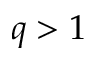<formula> <loc_0><loc_0><loc_500><loc_500>q > 1</formula> 